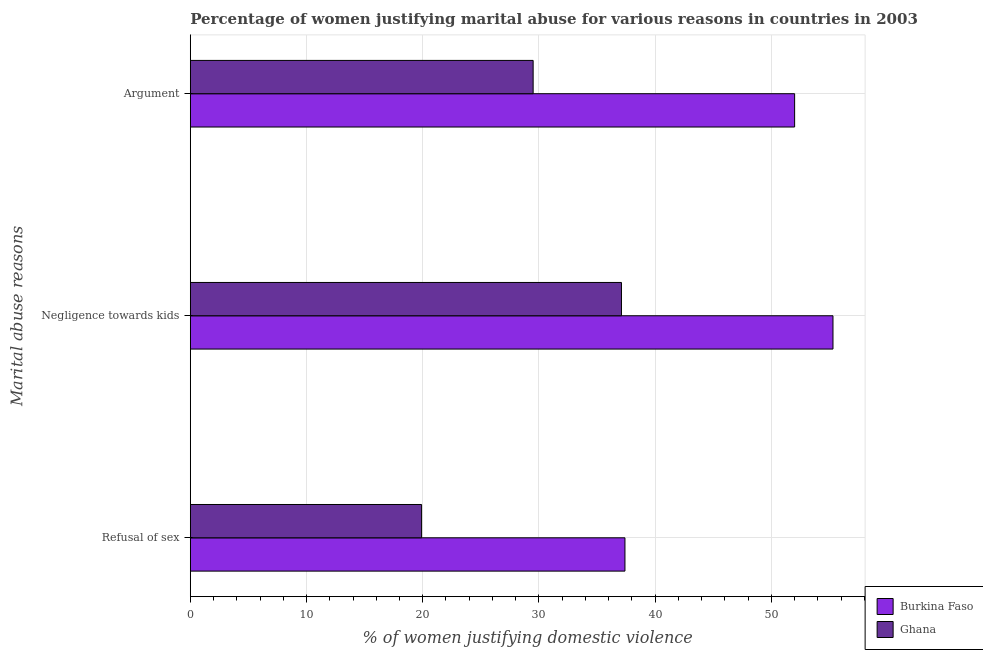How many different coloured bars are there?
Your answer should be very brief. 2. How many groups of bars are there?
Make the answer very short. 3. Are the number of bars per tick equal to the number of legend labels?
Offer a very short reply. Yes. How many bars are there on the 1st tick from the top?
Make the answer very short. 2. How many bars are there on the 1st tick from the bottom?
Offer a very short reply. 2. What is the label of the 3rd group of bars from the top?
Offer a terse response. Refusal of sex. What is the percentage of women justifying domestic violence due to refusal of sex in Ghana?
Make the answer very short. 19.9. Across all countries, what is the maximum percentage of women justifying domestic violence due to refusal of sex?
Your response must be concise. 37.4. Across all countries, what is the minimum percentage of women justifying domestic violence due to refusal of sex?
Give a very brief answer. 19.9. In which country was the percentage of women justifying domestic violence due to arguments maximum?
Your answer should be very brief. Burkina Faso. What is the total percentage of women justifying domestic violence due to refusal of sex in the graph?
Offer a very short reply. 57.3. What is the difference between the percentage of women justifying domestic violence due to negligence towards kids in Burkina Faso and that in Ghana?
Ensure brevity in your answer.  18.2. What is the difference between the percentage of women justifying domestic violence due to refusal of sex in Ghana and the percentage of women justifying domestic violence due to arguments in Burkina Faso?
Offer a very short reply. -32.1. What is the average percentage of women justifying domestic violence due to negligence towards kids per country?
Keep it short and to the point. 46.2. What is the difference between the percentage of women justifying domestic violence due to refusal of sex and percentage of women justifying domestic violence due to negligence towards kids in Ghana?
Make the answer very short. -17.2. In how many countries, is the percentage of women justifying domestic violence due to negligence towards kids greater than 2 %?
Offer a very short reply. 2. What is the ratio of the percentage of women justifying domestic violence due to refusal of sex in Burkina Faso to that in Ghana?
Provide a short and direct response. 1.88. Is the percentage of women justifying domestic violence due to negligence towards kids in Ghana less than that in Burkina Faso?
Offer a very short reply. Yes. Is the difference between the percentage of women justifying domestic violence due to negligence towards kids in Burkina Faso and Ghana greater than the difference between the percentage of women justifying domestic violence due to arguments in Burkina Faso and Ghana?
Offer a very short reply. No. What is the difference between the highest and the second highest percentage of women justifying domestic violence due to negligence towards kids?
Provide a short and direct response. 18.2. What does the 1st bar from the bottom in Negligence towards kids represents?
Offer a terse response. Burkina Faso. How many bars are there?
Offer a very short reply. 6. How many countries are there in the graph?
Provide a short and direct response. 2. What is the difference between two consecutive major ticks on the X-axis?
Ensure brevity in your answer.  10. Are the values on the major ticks of X-axis written in scientific E-notation?
Keep it short and to the point. No. Does the graph contain any zero values?
Make the answer very short. No. How are the legend labels stacked?
Your answer should be compact. Vertical. What is the title of the graph?
Provide a succinct answer. Percentage of women justifying marital abuse for various reasons in countries in 2003. Does "Guatemala" appear as one of the legend labels in the graph?
Your response must be concise. No. What is the label or title of the X-axis?
Ensure brevity in your answer.  % of women justifying domestic violence. What is the label or title of the Y-axis?
Provide a succinct answer. Marital abuse reasons. What is the % of women justifying domestic violence of Burkina Faso in Refusal of sex?
Give a very brief answer. 37.4. What is the % of women justifying domestic violence in Ghana in Refusal of sex?
Your answer should be compact. 19.9. What is the % of women justifying domestic violence of Burkina Faso in Negligence towards kids?
Provide a short and direct response. 55.3. What is the % of women justifying domestic violence of Ghana in Negligence towards kids?
Keep it short and to the point. 37.1. What is the % of women justifying domestic violence in Burkina Faso in Argument?
Your answer should be compact. 52. What is the % of women justifying domestic violence of Ghana in Argument?
Ensure brevity in your answer.  29.5. Across all Marital abuse reasons, what is the maximum % of women justifying domestic violence of Burkina Faso?
Provide a short and direct response. 55.3. Across all Marital abuse reasons, what is the maximum % of women justifying domestic violence of Ghana?
Provide a succinct answer. 37.1. Across all Marital abuse reasons, what is the minimum % of women justifying domestic violence of Burkina Faso?
Keep it short and to the point. 37.4. Across all Marital abuse reasons, what is the minimum % of women justifying domestic violence of Ghana?
Your answer should be very brief. 19.9. What is the total % of women justifying domestic violence of Burkina Faso in the graph?
Provide a succinct answer. 144.7. What is the total % of women justifying domestic violence of Ghana in the graph?
Your response must be concise. 86.5. What is the difference between the % of women justifying domestic violence of Burkina Faso in Refusal of sex and that in Negligence towards kids?
Provide a short and direct response. -17.9. What is the difference between the % of women justifying domestic violence of Ghana in Refusal of sex and that in Negligence towards kids?
Your answer should be compact. -17.2. What is the difference between the % of women justifying domestic violence in Burkina Faso in Refusal of sex and that in Argument?
Your answer should be compact. -14.6. What is the difference between the % of women justifying domestic violence in Ghana in Negligence towards kids and that in Argument?
Your response must be concise. 7.6. What is the difference between the % of women justifying domestic violence in Burkina Faso in Negligence towards kids and the % of women justifying domestic violence in Ghana in Argument?
Offer a terse response. 25.8. What is the average % of women justifying domestic violence in Burkina Faso per Marital abuse reasons?
Offer a very short reply. 48.23. What is the average % of women justifying domestic violence in Ghana per Marital abuse reasons?
Your answer should be very brief. 28.83. What is the difference between the % of women justifying domestic violence in Burkina Faso and % of women justifying domestic violence in Ghana in Refusal of sex?
Offer a terse response. 17.5. What is the difference between the % of women justifying domestic violence of Burkina Faso and % of women justifying domestic violence of Ghana in Argument?
Provide a succinct answer. 22.5. What is the ratio of the % of women justifying domestic violence of Burkina Faso in Refusal of sex to that in Negligence towards kids?
Make the answer very short. 0.68. What is the ratio of the % of women justifying domestic violence in Ghana in Refusal of sex to that in Negligence towards kids?
Give a very brief answer. 0.54. What is the ratio of the % of women justifying domestic violence of Burkina Faso in Refusal of sex to that in Argument?
Your response must be concise. 0.72. What is the ratio of the % of women justifying domestic violence of Ghana in Refusal of sex to that in Argument?
Offer a terse response. 0.67. What is the ratio of the % of women justifying domestic violence in Burkina Faso in Negligence towards kids to that in Argument?
Provide a succinct answer. 1.06. What is the ratio of the % of women justifying domestic violence in Ghana in Negligence towards kids to that in Argument?
Ensure brevity in your answer.  1.26. What is the difference between the highest and the lowest % of women justifying domestic violence in Ghana?
Keep it short and to the point. 17.2. 